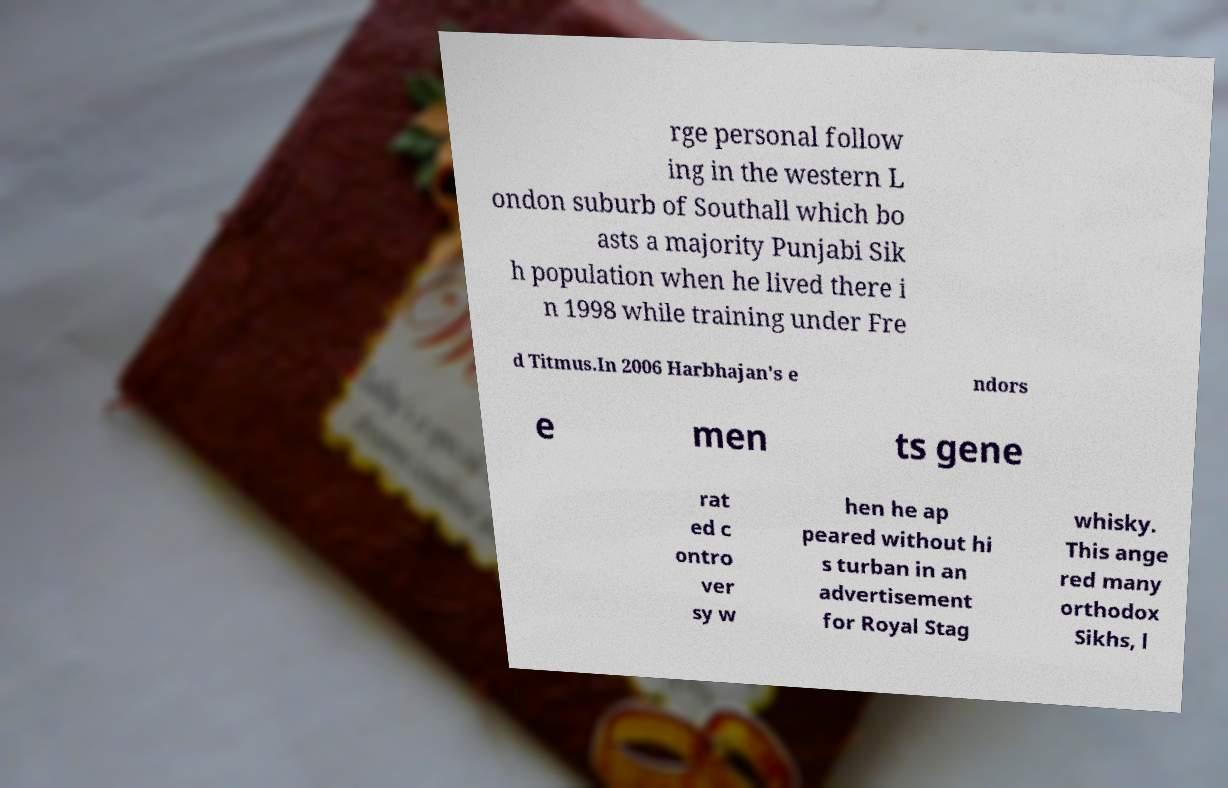There's text embedded in this image that I need extracted. Can you transcribe it verbatim? rge personal follow ing in the western L ondon suburb of Southall which bo asts a majority Punjabi Sik h population when he lived there i n 1998 while training under Fre d Titmus.In 2006 Harbhajan's e ndors e men ts gene rat ed c ontro ver sy w hen he ap peared without hi s turban in an advertisement for Royal Stag whisky. This ange red many orthodox Sikhs, l 